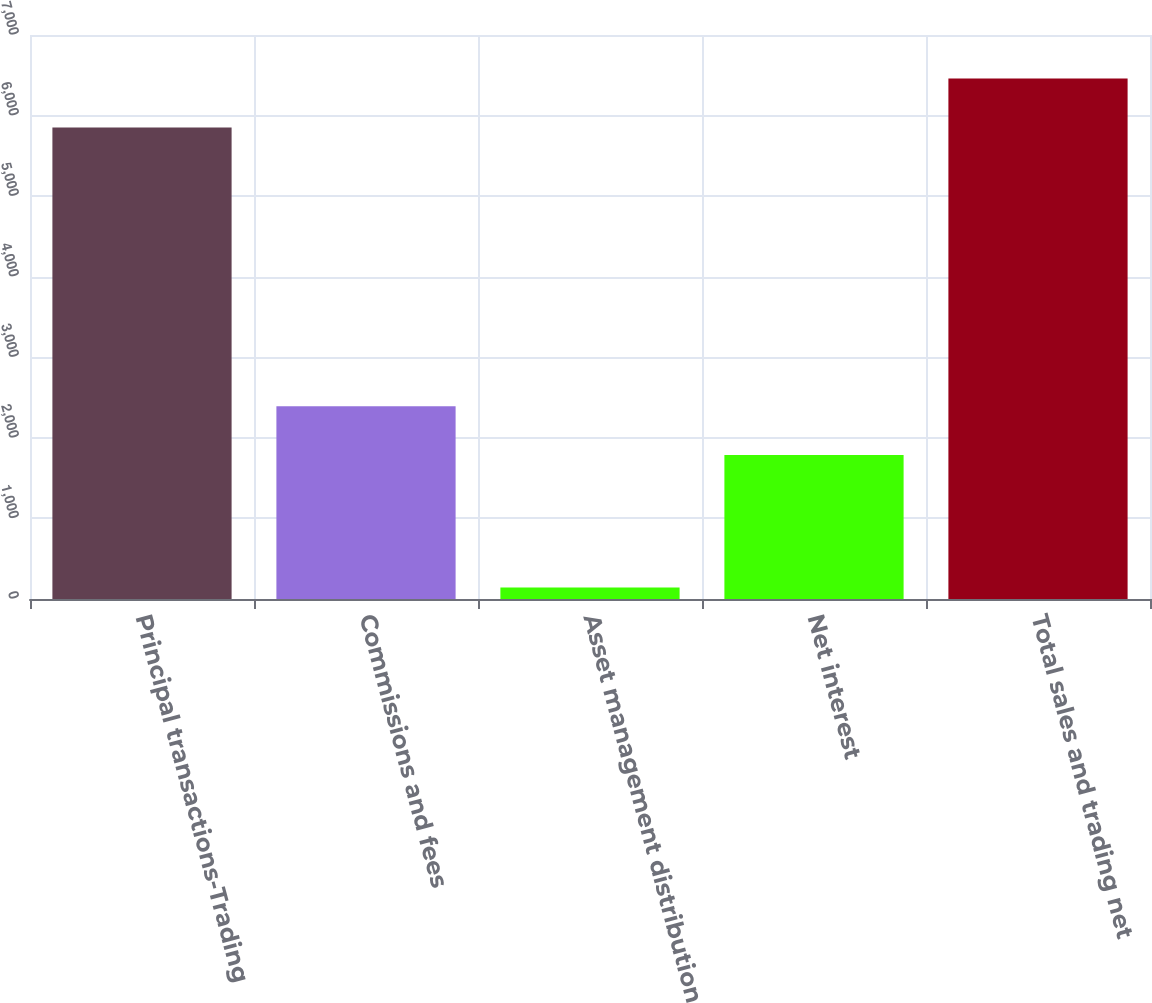<chart> <loc_0><loc_0><loc_500><loc_500><bar_chart><fcel>Principal transactions-Trading<fcel>Commissions and fees<fcel>Asset management distribution<fcel>Net interest<fcel>Total sales and trading net<nl><fcel>5853<fcel>2392.6<fcel>144<fcel>1786<fcel>6459.6<nl></chart> 